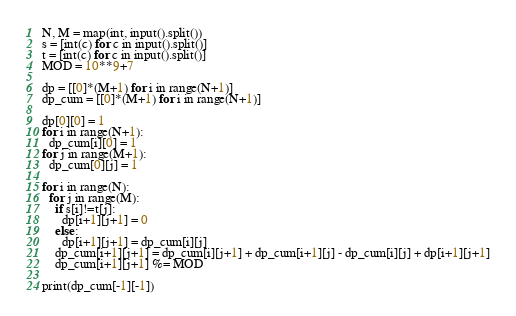Convert code to text. <code><loc_0><loc_0><loc_500><loc_500><_Python_>N, M = map(int, input().split())
s = [int(c) for c in input().split()]
t = [int(c) for c in input().split()]
MOD = 10**9+7

dp = [[0]*(M+1) for i in range(N+1)]
dp_cum = [[0]*(M+1) for i in range(N+1)]

dp[0][0] = 1
for i in range(N+1):
  dp_cum[i][0] = 1
for j in range(M+1):
  dp_cum[0][j] = 1
  
for i in range(N):
  for j in range(M):
    if s[i]!=t[j]:
      dp[i+1][j+1] = 0
    else:
      dp[i+1][j+1] = dp_cum[i][j]
    dp_cum[i+1][j+1] = dp_cum[i][j+1] + dp_cum[i+1][j] - dp_cum[i][j] + dp[i+1][j+1]
    dp_cum[i+1][j+1] %= MOD

print(dp_cum[-1][-1])</code> 